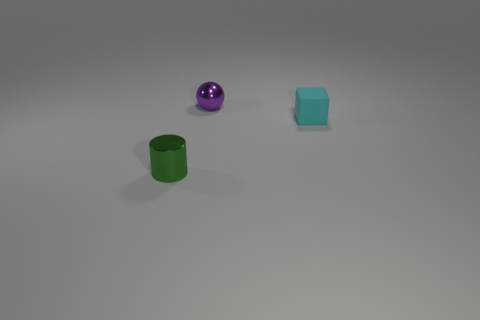How many objects are visible in the image? Three objects are present in the image: a purple ball, a teal cube, and a green cylindrical object. 